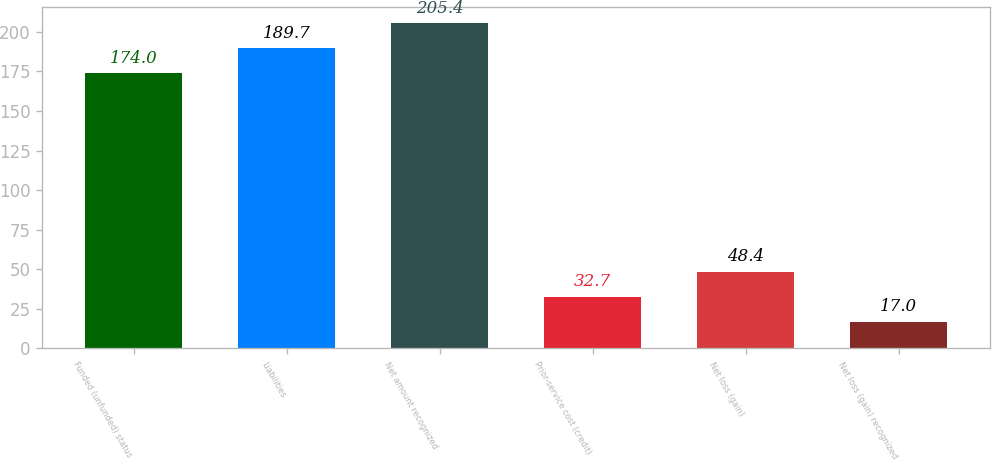Convert chart to OTSL. <chart><loc_0><loc_0><loc_500><loc_500><bar_chart><fcel>Funded (unfunded) status<fcel>Liabilities<fcel>Net amount recognized<fcel>Prior-service cost (credit)<fcel>Net loss (gain)<fcel>Net loss (gain) recognized<nl><fcel>174<fcel>189.7<fcel>205.4<fcel>32.7<fcel>48.4<fcel>17<nl></chart> 